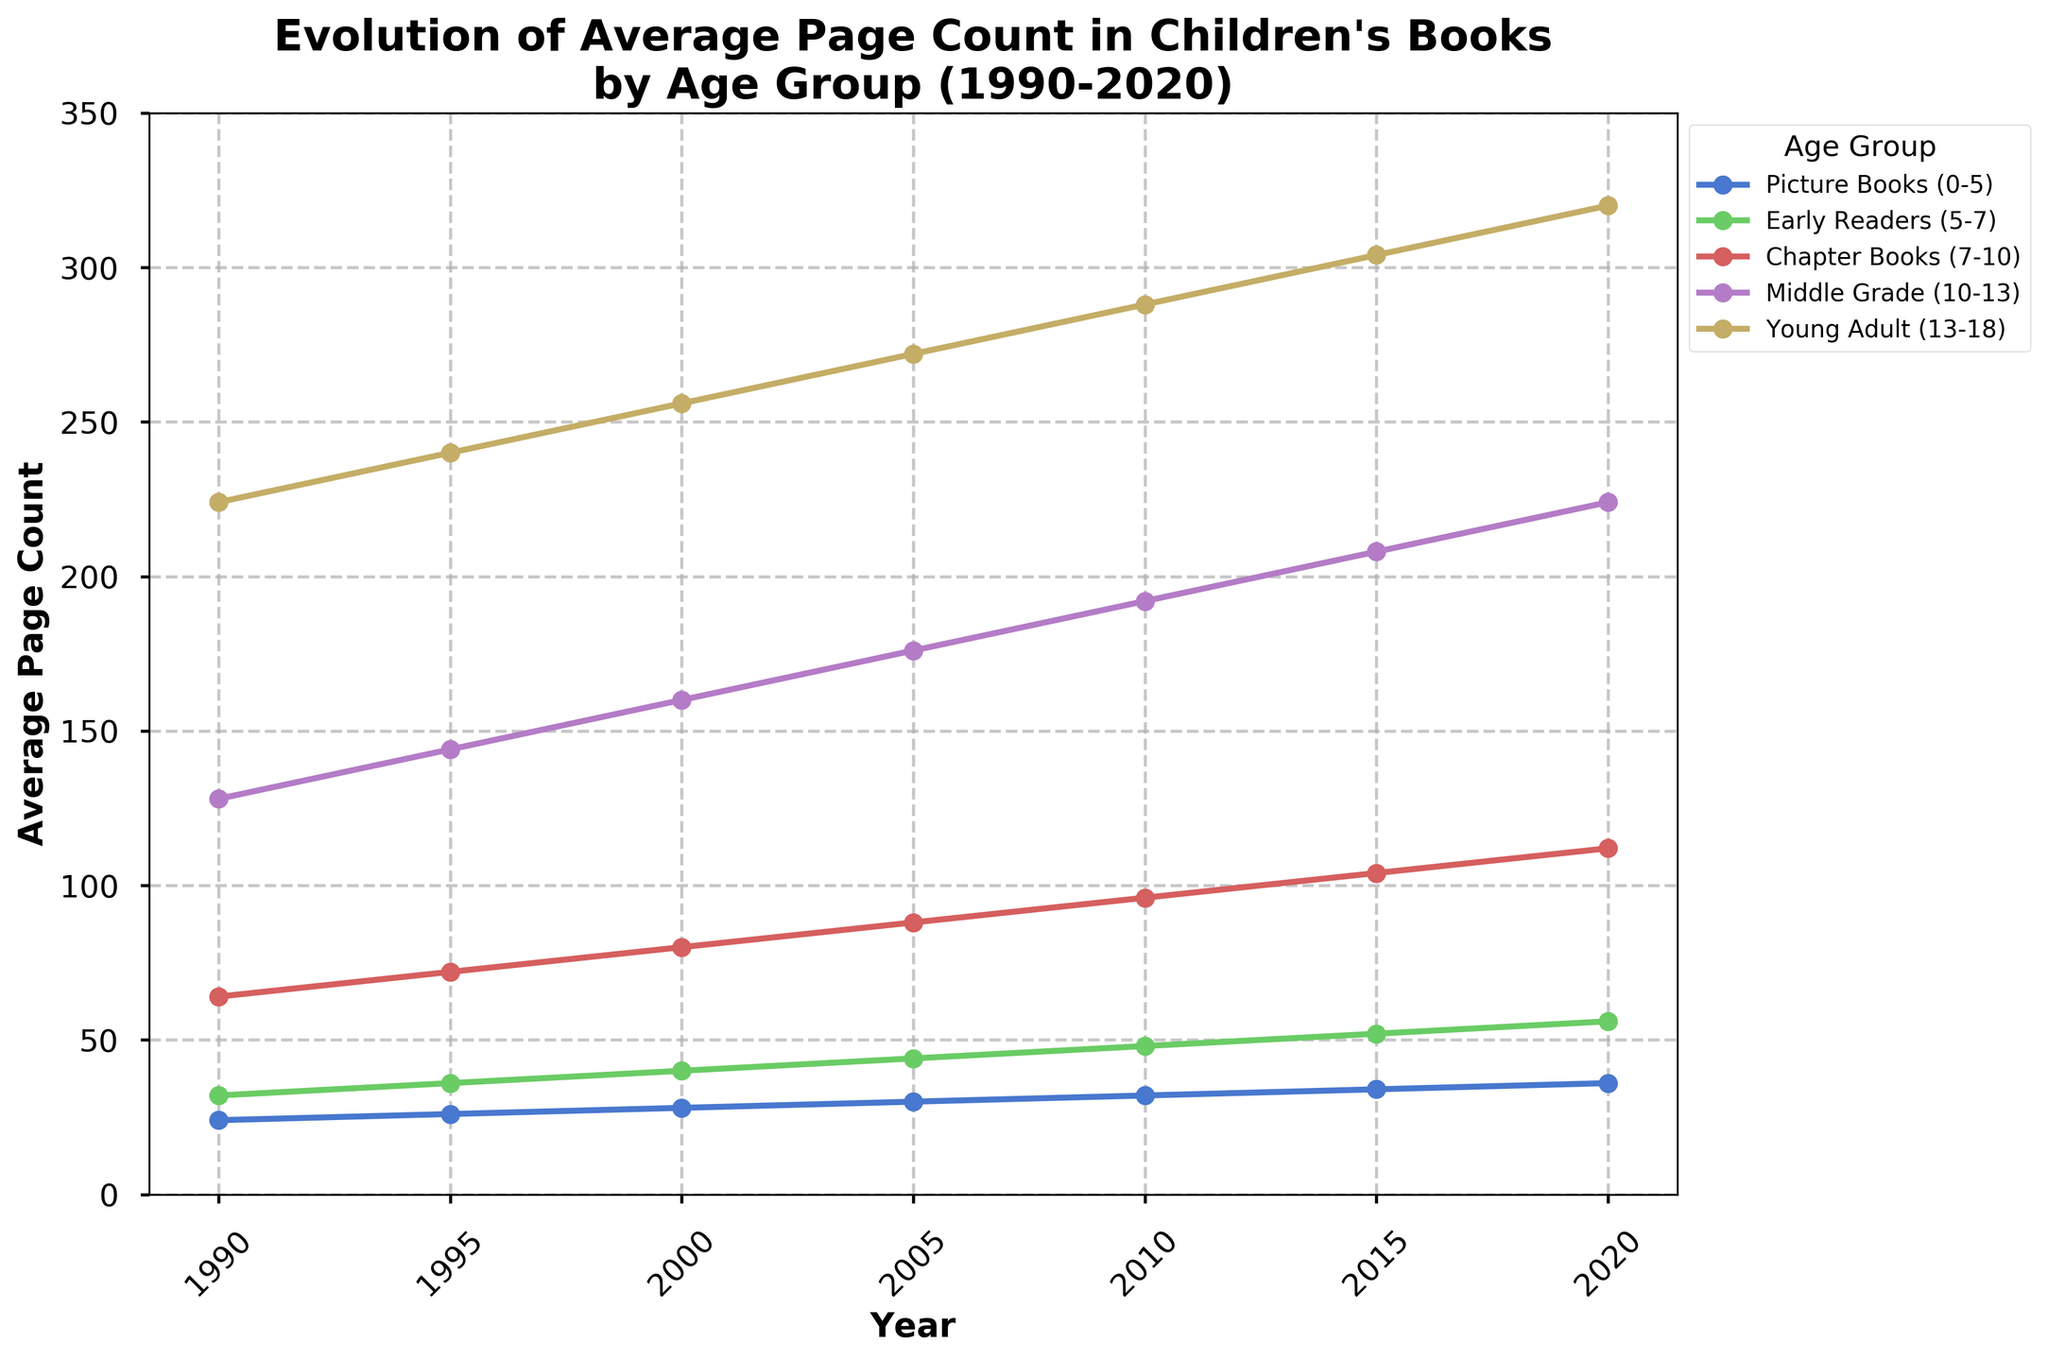What is the trend in the average page count for Picture Books (0-5) from 1990 to 2020? The average page count for Picture Books increases steadily over the 30-year period. Starting at 24 pages in 1990, it grows consistently by 2 pages every 5 years, reaching 36 pages in 2020.
Answer: Increasing trend Which age group saw the greatest increase in average page count over the period? To determine the greatest increase, we need to calculate the differences between the last value (2020) and the first value (1990) for each age group. Picture Books: 36-24=12, Early Readers: 56-32=24, Chapter Books: 112-64=48, Middle Grade: 224-128=96, Young Adult: 320-224=96. The greatest increases are observed in the Middle Grade and Young Adult age groups, both with an increase of 96 pages.
Answer: Middle Grade and Young Adult By how many pages did the average page count of Young Adult (13-18) books increase from 2000 to 2010? For Young Adult books, subtract the 2000 value from the 2010 value: 288 (2010) - 256 (2000) = 32 pages.
Answer: 32 pages Between which two consecutive years did Chapter Books (7-10) see the highest increase in average page count? Look at the increments between each consecutive 5-year period: 2000-1995: 80-72=8, 2005-2000: 88-80=8, 2010-2005: 96-88=8, 2015-2010: 104-96=8, 2020-2015: 112-104=8. All intervals show the same increase.
Answer: All consecutive intervals show the same increase How much higher is the average page count for Middle Grade (10-13) books in 2015 compared to Picture Books (0-5) in 2015? Subtract the average page count of Picture Books from that of Middle Grade books in 2015: 208 (Middle Grade) - 34 (Picture Books) = 174.
Answer: 174 pages Which age group consistently has the highest average page count throughout the period? By observing the lines on the chart, the Young Adult (13-18) age group has the highest average page count in every year from 1990 to 2020.
Answer: Young Adult (13-18) Were there any age groups whose average page count did not increase every five years? The lines on the chart show a steady increase for each age group throughout the period, indicating that every age group had an increasing average page count every five years.
Answer: No What is the difference in the average page count of the age group with the highest average page count and the age group with the lowest average page count in 2020? In 2020, the highest average page count is for Young Adult with 320 pages and the lowest is for Picture Books with 36 pages. The difference is 320 - 36 = 284 pages.
Answer: 284 pages Which age group had the smallest increase in average page count from 1990 to 2000? Calculate the increase for each group from 1990 to 2000: Picture Books: 28-24=4, Early Readers: 40-32=8, Chapter Books: 80-64=16, Middle Grade: 160-128=32, Young Adult: 256-224=32. Picture Books had the smallest increase of 4 pages.
Answer: Picture Books (0-5) Which age group’s average page count increased by exactly 16 pages between 2010 and 2015? Calculate the increase for each group in this period: Picture Books: 34-32=2, Early Readers: 52-48=4, Chapter Books: 104-96=8, Middle Grade: 208-192=16, Young Adult: 304-288=16. Both Middle Grade and Young Adult increased by exactly 16 pages.
Answer: Middle Grade and Young Adult 